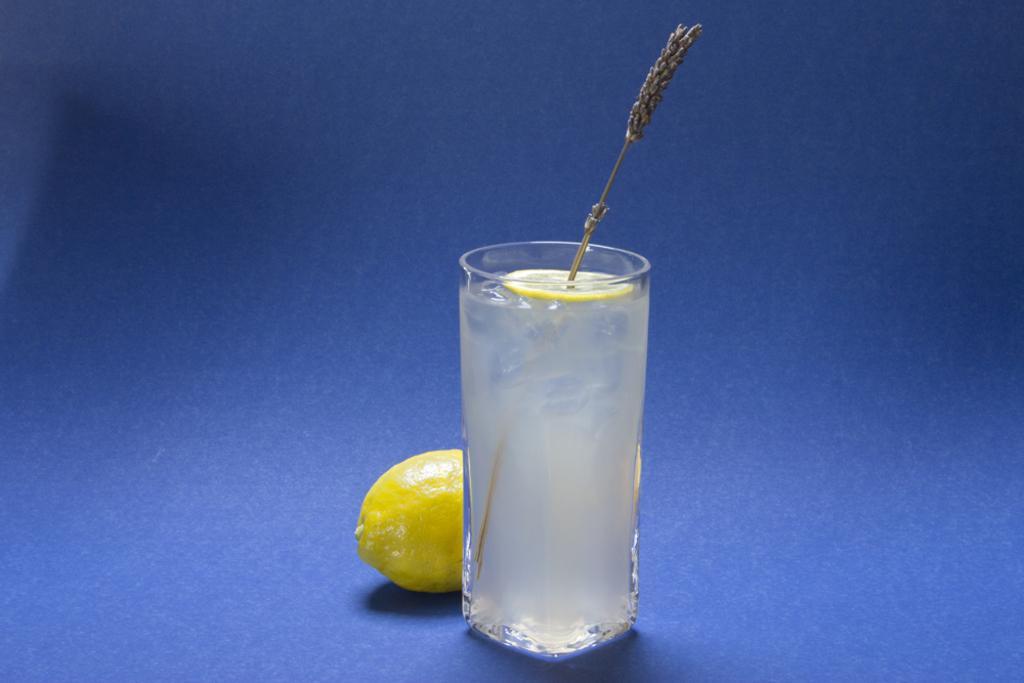Can you describe this image briefly? In the image on the blue surface there is a glass with drink. On the drink inside the glass there is a lemon slice with stick. Behind the glass there is a lemon. 